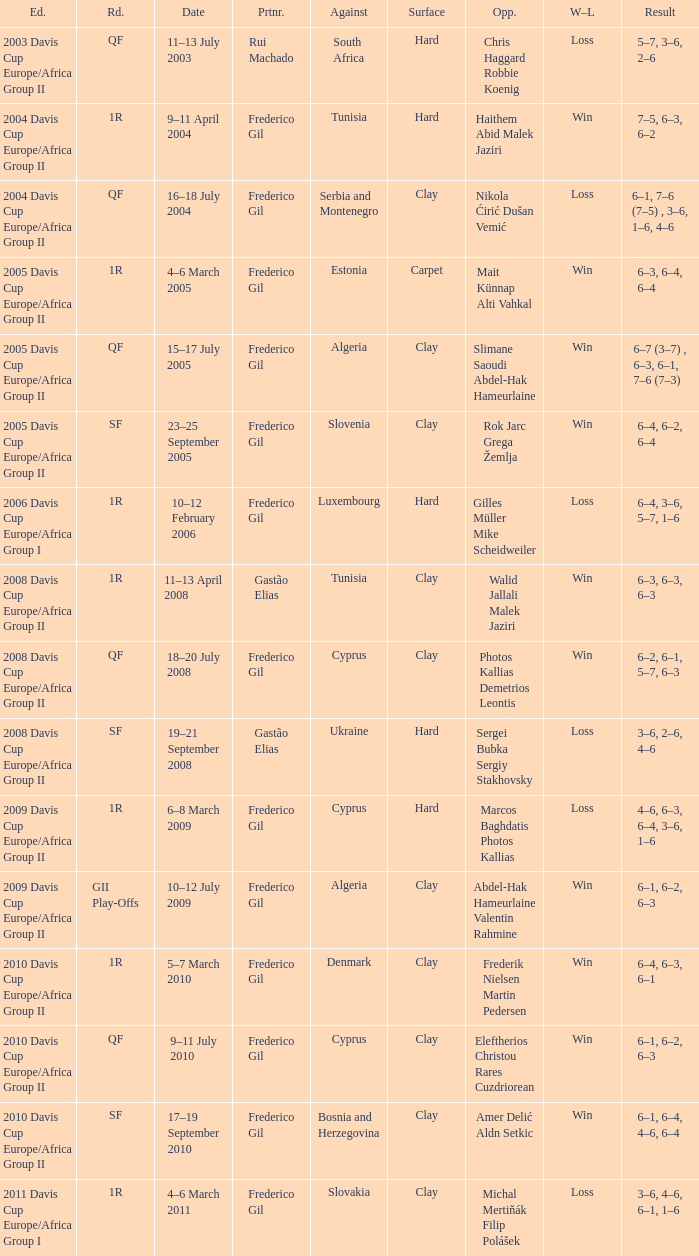How many rounds were there in the 2006 davis cup europe/africa group I? 1.0. 